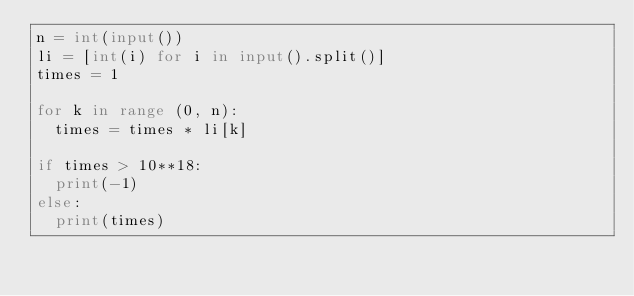Convert code to text. <code><loc_0><loc_0><loc_500><loc_500><_Python_>n = int(input())
li = [int(i) for i in input().split()]
times = 1

for k in range (0, n):
  times = times * li[k]

if times > 10**18:
  print(-1)
else:
  print(times)</code> 